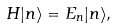Convert formula to latex. <formula><loc_0><loc_0><loc_500><loc_500>H | n \rangle = E _ { n } | n \rangle ,</formula> 